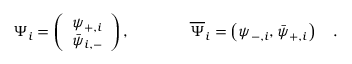Convert formula to latex. <formula><loc_0><loc_0><loc_500><loc_500>\Psi _ { i } = \left ( \begin{array} { l } { { \psi _ { + , i } } } \\ { { \bar { \psi } _ { i , - } } } \end{array} \right ) , \quad \overline { \Psi } _ { i } = \left ( \psi _ { - , i } , \bar { \psi } _ { + , i } \right ) \quad .</formula> 